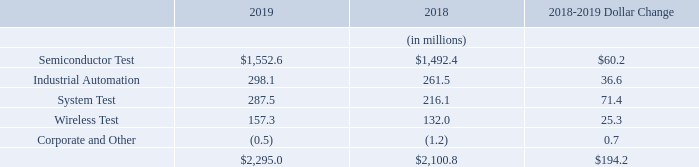Revenues
Revenues for our reportable segments were as follows:
The increase in Semiconductor Test revenues of $60.2 million, or 4%, from 2018 to 2019 was driven primarily by an increase in semiconductor tester sales for 5G infrastructure and image sensors and higher service revenue, partially offset by a decrease in sales in the automotive and analog test segments.
The increase in Industrial Automation revenues of $36.6 million, or 14%, from 2018 to 2019 was primarily due to higher demand for collaborative robots. The MiR acquisition was completed in April 2018.
The increase in System Test revenues of $71.4 million, or 33%, from 2018 to 2019 was primarily due to higher sales in Storage Test of 3.5” hard disk drive testers, higher sales in Defense/Aerospace test instrumentation and systems, and higher sales in Production Board Test from higher 5G demand.
The increase in Wireless Test revenues of $25.3 million, or 19%, from 2018 to 2019 was primarily due to higher demand for millimeter wave and cellular test products driven by new wireless standards and 5G, partially offset by lower sales in connectivity test products and services.
What was the change in Industrial Automation revenues? $36.6 million. What was the change in System Test revenues? $71.4 million. What were the reportable segments in the table? Semiconductor test, industrial automation, system test, wireless test, corporate and other. In which year was Wireless Test larger? 157.3>132.0
Answer: 2019. What was the average revenue from System Test in 2018 and 2019?
Answer scale should be: million. (287.5+216.1)/2
Answer: 251.8. What was the average total revenue in 2018 and 2019?
Answer scale should be: million. (2,295.0+2,100.8)/2
Answer: 2197.9. 